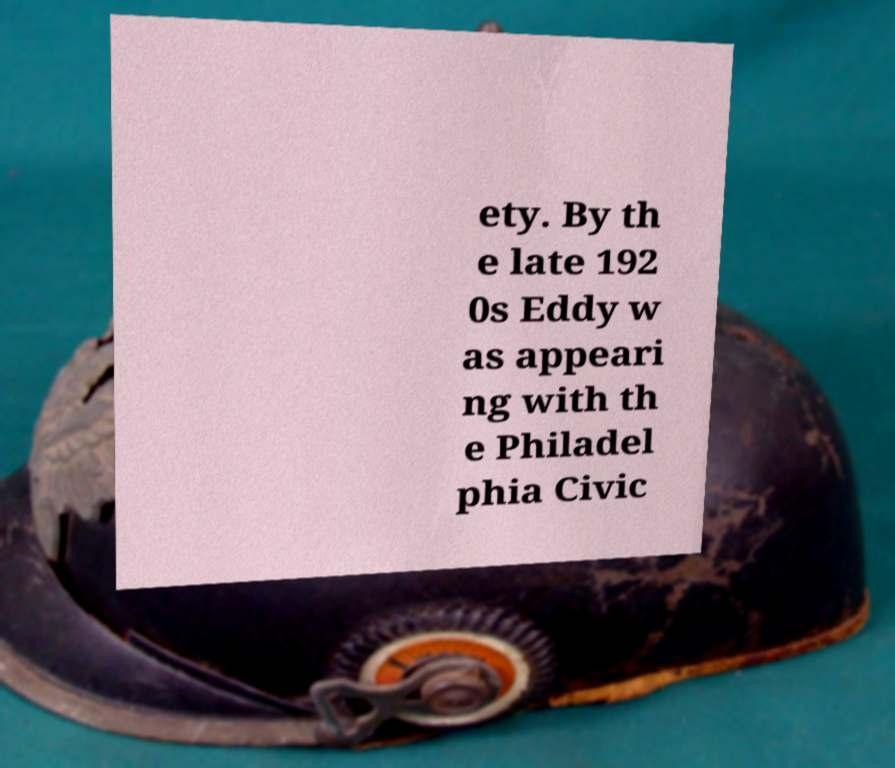Can you accurately transcribe the text from the provided image for me? ety. By th e late 192 0s Eddy w as appeari ng with th e Philadel phia Civic 